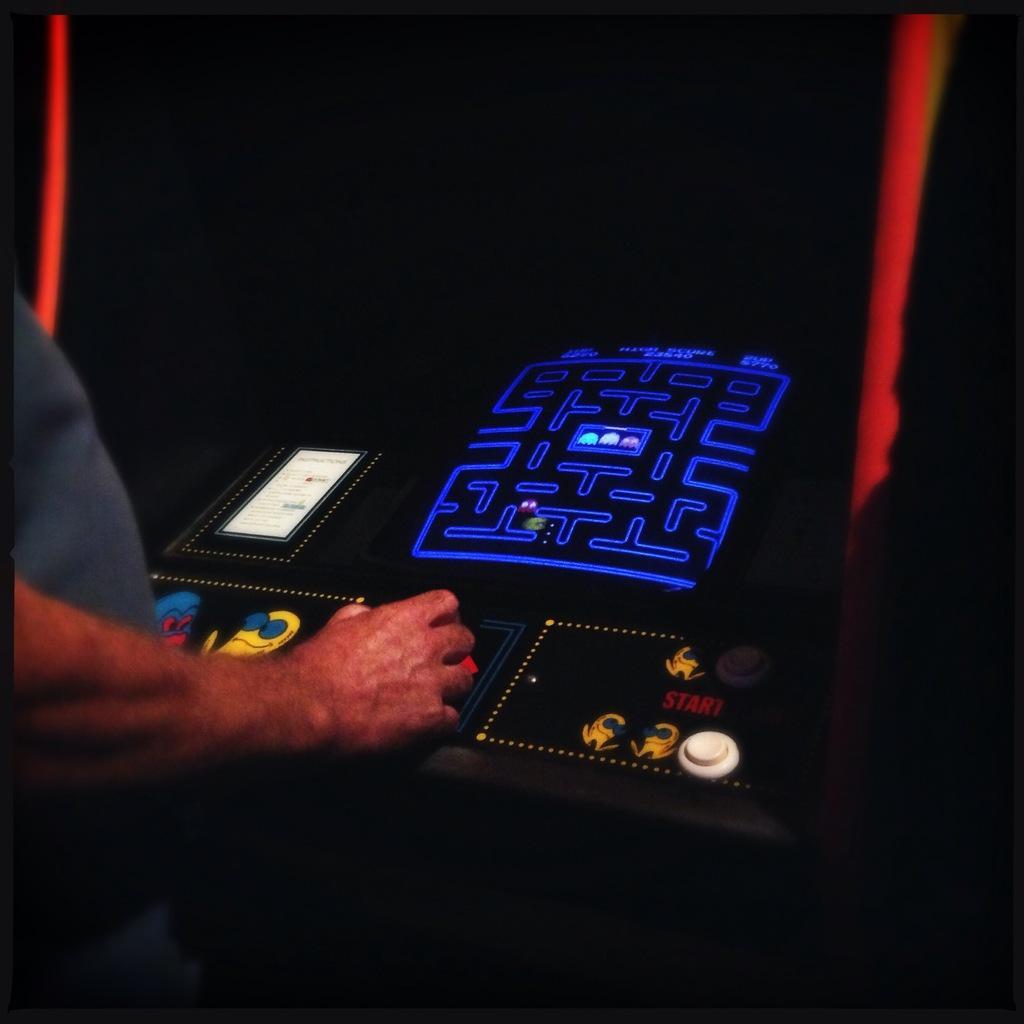Could you give a brief overview of what you see in this image? In this image I can see a person wearing grey colored dress is standing in front of a gaming machine which is black, blue, white and yellow in color. 